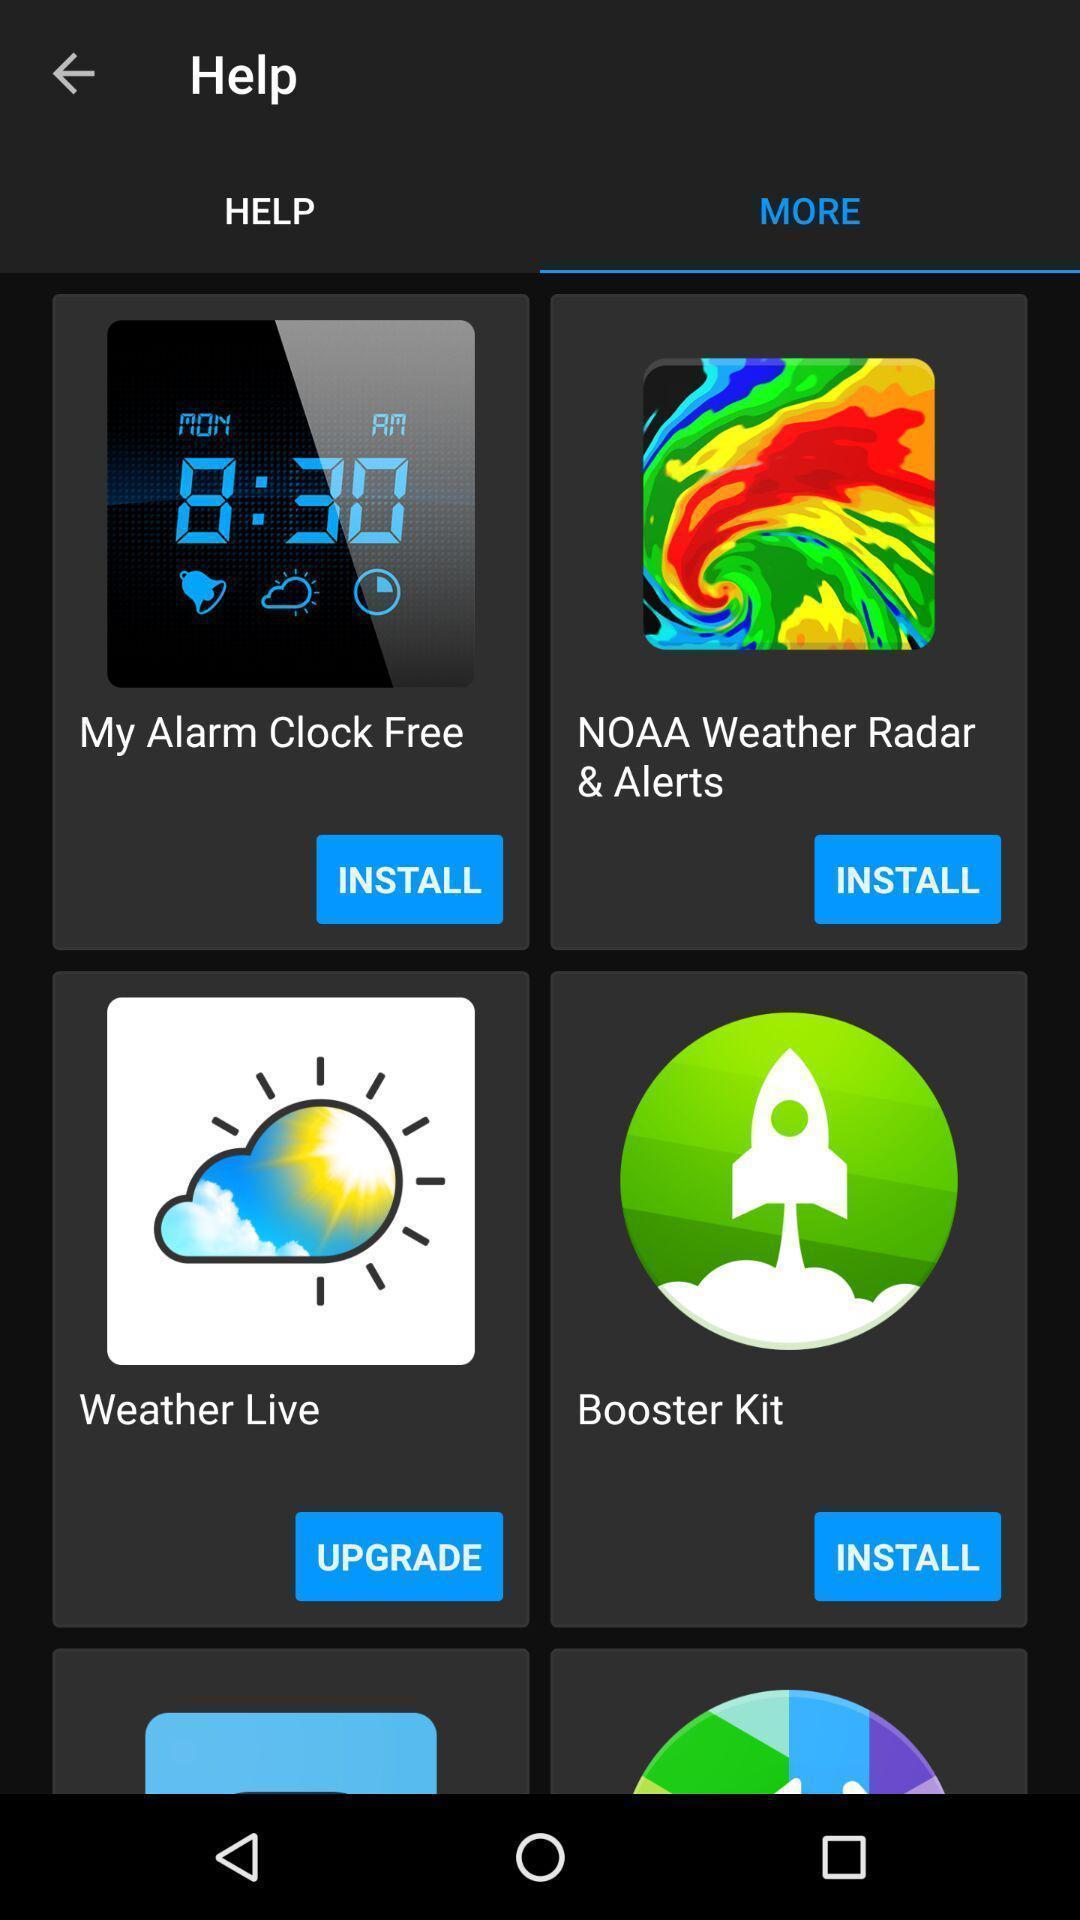Please provide a description for this image. Page displaying the various app installations. 